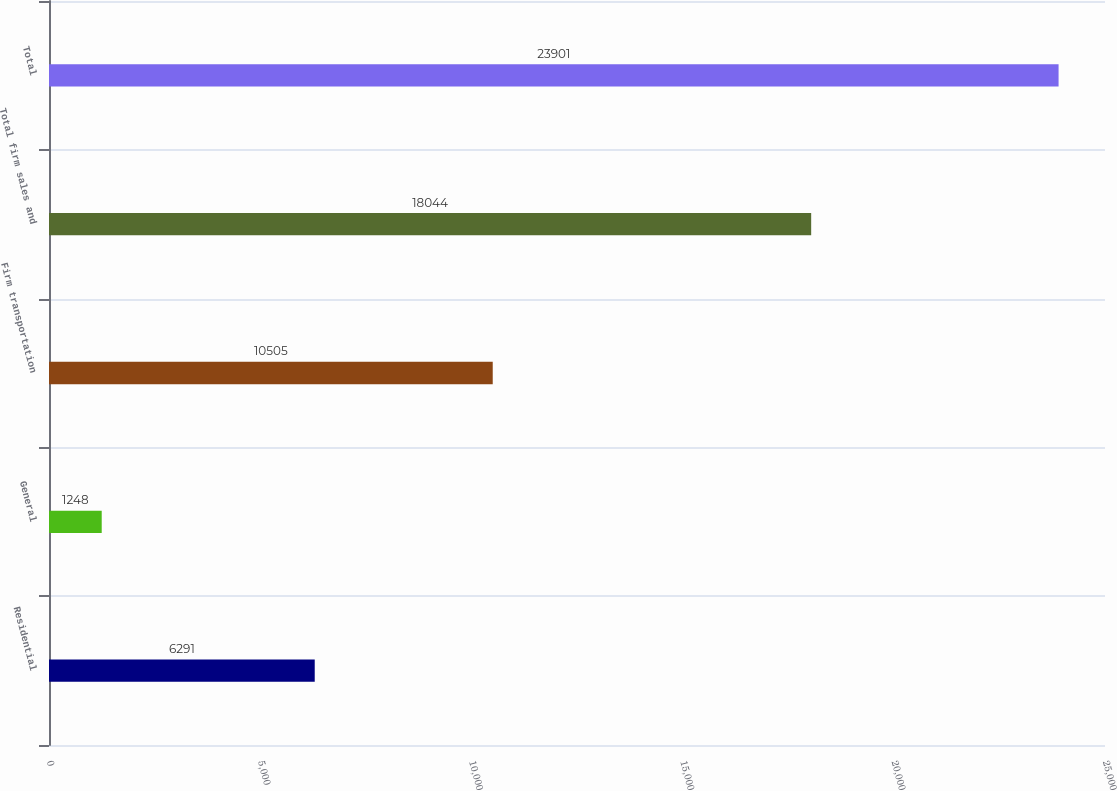Convert chart to OTSL. <chart><loc_0><loc_0><loc_500><loc_500><bar_chart><fcel>Residential<fcel>General<fcel>Firm transportation<fcel>Total firm sales and<fcel>Total<nl><fcel>6291<fcel>1248<fcel>10505<fcel>18044<fcel>23901<nl></chart> 